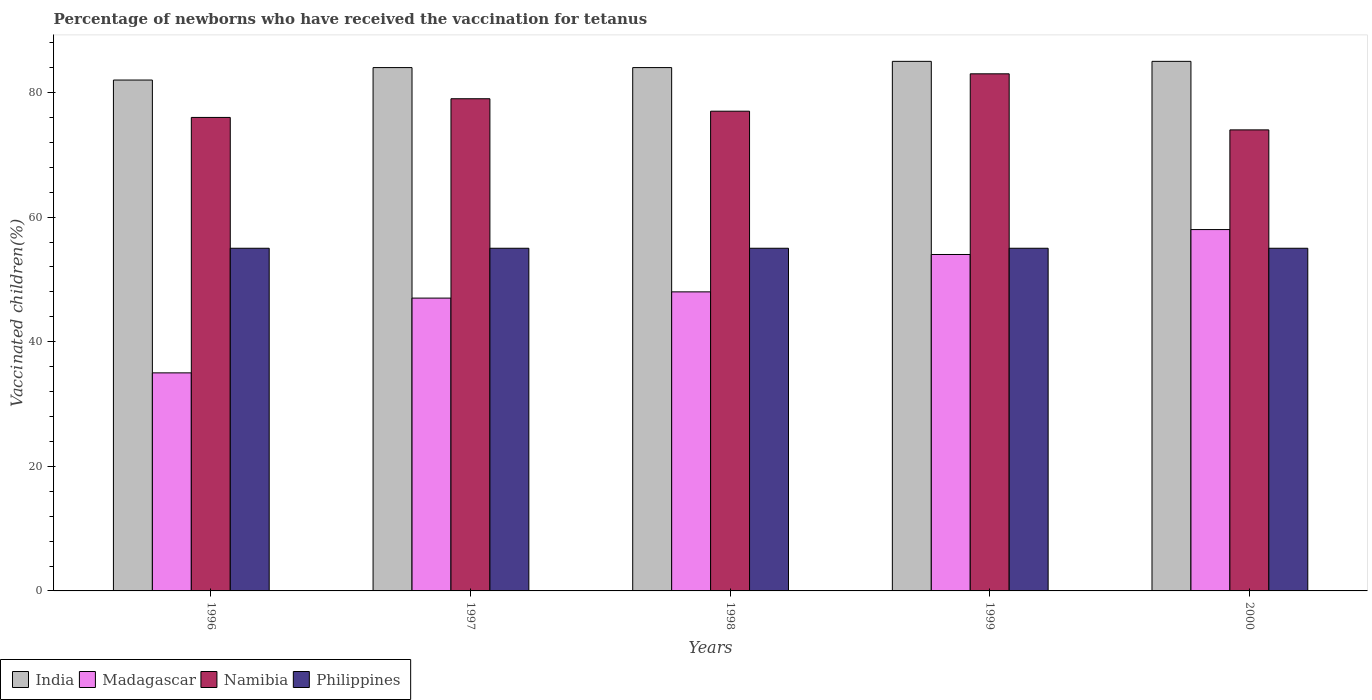Are the number of bars on each tick of the X-axis equal?
Keep it short and to the point. Yes. How many bars are there on the 3rd tick from the left?
Offer a very short reply. 4. What is the percentage of vaccinated children in Philippines in 1997?
Your answer should be very brief. 55. Across all years, what is the maximum percentage of vaccinated children in Philippines?
Give a very brief answer. 55. Across all years, what is the minimum percentage of vaccinated children in Philippines?
Your answer should be very brief. 55. In which year was the percentage of vaccinated children in Philippines maximum?
Offer a terse response. 1996. What is the total percentage of vaccinated children in Namibia in the graph?
Offer a terse response. 389. What is the difference between the percentage of vaccinated children in Madagascar in 1996 and that in 1997?
Keep it short and to the point. -12. What is the difference between the percentage of vaccinated children in India in 2000 and the percentage of vaccinated children in Madagascar in 1996?
Your response must be concise. 50. What is the average percentage of vaccinated children in Philippines per year?
Offer a very short reply. 55. In the year 1997, what is the difference between the percentage of vaccinated children in India and percentage of vaccinated children in Philippines?
Offer a very short reply. 29. In how many years, is the percentage of vaccinated children in Madagascar greater than 72 %?
Offer a very short reply. 0. What is the ratio of the percentage of vaccinated children in India in 1996 to that in 2000?
Keep it short and to the point. 0.96. What is the difference between the highest and the second highest percentage of vaccinated children in Madagascar?
Provide a succinct answer. 4. Is it the case that in every year, the sum of the percentage of vaccinated children in India and percentage of vaccinated children in Philippines is greater than the sum of percentage of vaccinated children in Namibia and percentage of vaccinated children in Madagascar?
Offer a terse response. Yes. What does the 3rd bar from the right in 1996 represents?
Your answer should be very brief. Madagascar. Is it the case that in every year, the sum of the percentage of vaccinated children in Namibia and percentage of vaccinated children in Philippines is greater than the percentage of vaccinated children in India?
Your response must be concise. Yes. Are all the bars in the graph horizontal?
Provide a short and direct response. No. How many years are there in the graph?
Give a very brief answer. 5. Does the graph contain grids?
Offer a terse response. No. What is the title of the graph?
Your answer should be very brief. Percentage of newborns who have received the vaccination for tetanus. Does "Guinea-Bissau" appear as one of the legend labels in the graph?
Provide a short and direct response. No. What is the label or title of the Y-axis?
Provide a short and direct response. Vaccinated children(%). What is the Vaccinated children(%) in India in 1996?
Provide a succinct answer. 82. What is the Vaccinated children(%) of Madagascar in 1996?
Offer a very short reply. 35. What is the Vaccinated children(%) of Philippines in 1996?
Give a very brief answer. 55. What is the Vaccinated children(%) in Madagascar in 1997?
Make the answer very short. 47. What is the Vaccinated children(%) of Namibia in 1997?
Your response must be concise. 79. What is the Vaccinated children(%) of India in 1998?
Make the answer very short. 84. What is the Vaccinated children(%) of Madagascar in 1998?
Your answer should be compact. 48. What is the Vaccinated children(%) in Philippines in 1998?
Your answer should be very brief. 55. What is the Vaccinated children(%) in India in 1999?
Offer a very short reply. 85. What is the Vaccinated children(%) of Madagascar in 1999?
Ensure brevity in your answer.  54. What is the Vaccinated children(%) in Philippines in 1999?
Offer a terse response. 55. What is the Vaccinated children(%) in India in 2000?
Offer a very short reply. 85. What is the Vaccinated children(%) in Madagascar in 2000?
Make the answer very short. 58. What is the Vaccinated children(%) in Namibia in 2000?
Ensure brevity in your answer.  74. What is the Vaccinated children(%) of Philippines in 2000?
Provide a short and direct response. 55. Across all years, what is the maximum Vaccinated children(%) of India?
Your answer should be compact. 85. Across all years, what is the minimum Vaccinated children(%) in Madagascar?
Your response must be concise. 35. Across all years, what is the minimum Vaccinated children(%) in Namibia?
Offer a terse response. 74. Across all years, what is the minimum Vaccinated children(%) of Philippines?
Provide a short and direct response. 55. What is the total Vaccinated children(%) in India in the graph?
Your answer should be compact. 420. What is the total Vaccinated children(%) in Madagascar in the graph?
Your answer should be compact. 242. What is the total Vaccinated children(%) of Namibia in the graph?
Your response must be concise. 389. What is the total Vaccinated children(%) of Philippines in the graph?
Your response must be concise. 275. What is the difference between the Vaccinated children(%) in India in 1996 and that in 1997?
Your answer should be very brief. -2. What is the difference between the Vaccinated children(%) of Madagascar in 1996 and that in 1997?
Offer a terse response. -12. What is the difference between the Vaccinated children(%) in Namibia in 1996 and that in 1998?
Keep it short and to the point. -1. What is the difference between the Vaccinated children(%) in Philippines in 1996 and that in 1998?
Your response must be concise. 0. What is the difference between the Vaccinated children(%) in Namibia in 1996 and that in 1999?
Keep it short and to the point. -7. What is the difference between the Vaccinated children(%) in Philippines in 1996 and that in 1999?
Make the answer very short. 0. What is the difference between the Vaccinated children(%) in Madagascar in 1996 and that in 2000?
Your answer should be compact. -23. What is the difference between the Vaccinated children(%) of Namibia in 1996 and that in 2000?
Your answer should be very brief. 2. What is the difference between the Vaccinated children(%) of Philippines in 1996 and that in 2000?
Your answer should be very brief. 0. What is the difference between the Vaccinated children(%) in India in 1997 and that in 1998?
Your response must be concise. 0. What is the difference between the Vaccinated children(%) of India in 1997 and that in 1999?
Make the answer very short. -1. What is the difference between the Vaccinated children(%) in Madagascar in 1997 and that in 1999?
Your answer should be compact. -7. What is the difference between the Vaccinated children(%) in India in 1997 and that in 2000?
Make the answer very short. -1. What is the difference between the Vaccinated children(%) in Philippines in 1997 and that in 2000?
Offer a very short reply. 0. What is the difference between the Vaccinated children(%) of India in 1998 and that in 1999?
Make the answer very short. -1. What is the difference between the Vaccinated children(%) in Namibia in 1998 and that in 1999?
Offer a terse response. -6. What is the difference between the Vaccinated children(%) in Philippines in 1998 and that in 1999?
Provide a short and direct response. 0. What is the difference between the Vaccinated children(%) in Madagascar in 1998 and that in 2000?
Make the answer very short. -10. What is the difference between the Vaccinated children(%) in Namibia in 1998 and that in 2000?
Keep it short and to the point. 3. What is the difference between the Vaccinated children(%) in Madagascar in 1999 and that in 2000?
Ensure brevity in your answer.  -4. What is the difference between the Vaccinated children(%) of Namibia in 1999 and that in 2000?
Give a very brief answer. 9. What is the difference between the Vaccinated children(%) in Philippines in 1999 and that in 2000?
Ensure brevity in your answer.  0. What is the difference between the Vaccinated children(%) of India in 1996 and the Vaccinated children(%) of Madagascar in 1997?
Make the answer very short. 35. What is the difference between the Vaccinated children(%) of Madagascar in 1996 and the Vaccinated children(%) of Namibia in 1997?
Make the answer very short. -44. What is the difference between the Vaccinated children(%) in Madagascar in 1996 and the Vaccinated children(%) in Philippines in 1997?
Your answer should be compact. -20. What is the difference between the Vaccinated children(%) of India in 1996 and the Vaccinated children(%) of Namibia in 1998?
Offer a very short reply. 5. What is the difference between the Vaccinated children(%) in Madagascar in 1996 and the Vaccinated children(%) in Namibia in 1998?
Give a very brief answer. -42. What is the difference between the Vaccinated children(%) of Madagascar in 1996 and the Vaccinated children(%) of Philippines in 1998?
Provide a short and direct response. -20. What is the difference between the Vaccinated children(%) of India in 1996 and the Vaccinated children(%) of Philippines in 1999?
Provide a short and direct response. 27. What is the difference between the Vaccinated children(%) in Madagascar in 1996 and the Vaccinated children(%) in Namibia in 1999?
Offer a very short reply. -48. What is the difference between the Vaccinated children(%) in Madagascar in 1996 and the Vaccinated children(%) in Philippines in 1999?
Provide a short and direct response. -20. What is the difference between the Vaccinated children(%) of India in 1996 and the Vaccinated children(%) of Philippines in 2000?
Offer a terse response. 27. What is the difference between the Vaccinated children(%) of Madagascar in 1996 and the Vaccinated children(%) of Namibia in 2000?
Your answer should be very brief. -39. What is the difference between the Vaccinated children(%) of Madagascar in 1996 and the Vaccinated children(%) of Philippines in 2000?
Make the answer very short. -20. What is the difference between the Vaccinated children(%) in India in 1997 and the Vaccinated children(%) in Namibia in 1998?
Your response must be concise. 7. What is the difference between the Vaccinated children(%) in India in 1997 and the Vaccinated children(%) in Philippines in 1998?
Offer a very short reply. 29. What is the difference between the Vaccinated children(%) of Madagascar in 1997 and the Vaccinated children(%) of Philippines in 1998?
Give a very brief answer. -8. What is the difference between the Vaccinated children(%) in India in 1997 and the Vaccinated children(%) in Philippines in 1999?
Keep it short and to the point. 29. What is the difference between the Vaccinated children(%) of Madagascar in 1997 and the Vaccinated children(%) of Namibia in 1999?
Keep it short and to the point. -36. What is the difference between the Vaccinated children(%) in Namibia in 1997 and the Vaccinated children(%) in Philippines in 1999?
Offer a very short reply. 24. What is the difference between the Vaccinated children(%) of India in 1997 and the Vaccinated children(%) of Namibia in 2000?
Offer a very short reply. 10. What is the difference between the Vaccinated children(%) in India in 1997 and the Vaccinated children(%) in Philippines in 2000?
Give a very brief answer. 29. What is the difference between the Vaccinated children(%) in Madagascar in 1997 and the Vaccinated children(%) in Philippines in 2000?
Offer a very short reply. -8. What is the difference between the Vaccinated children(%) of India in 1998 and the Vaccinated children(%) of Philippines in 1999?
Keep it short and to the point. 29. What is the difference between the Vaccinated children(%) in Madagascar in 1998 and the Vaccinated children(%) in Namibia in 1999?
Your response must be concise. -35. What is the difference between the Vaccinated children(%) of Madagascar in 1998 and the Vaccinated children(%) of Philippines in 1999?
Your response must be concise. -7. What is the difference between the Vaccinated children(%) of India in 1998 and the Vaccinated children(%) of Madagascar in 2000?
Give a very brief answer. 26. What is the difference between the Vaccinated children(%) of India in 1998 and the Vaccinated children(%) of Philippines in 2000?
Offer a terse response. 29. What is the difference between the Vaccinated children(%) of Madagascar in 1998 and the Vaccinated children(%) of Philippines in 2000?
Keep it short and to the point. -7. What is the difference between the Vaccinated children(%) of Namibia in 1998 and the Vaccinated children(%) of Philippines in 2000?
Make the answer very short. 22. What is the difference between the Vaccinated children(%) in India in 1999 and the Vaccinated children(%) in Philippines in 2000?
Offer a terse response. 30. What is the difference between the Vaccinated children(%) of Madagascar in 1999 and the Vaccinated children(%) of Philippines in 2000?
Your answer should be very brief. -1. What is the average Vaccinated children(%) of Madagascar per year?
Make the answer very short. 48.4. What is the average Vaccinated children(%) in Namibia per year?
Your response must be concise. 77.8. What is the average Vaccinated children(%) in Philippines per year?
Make the answer very short. 55. In the year 1996, what is the difference between the Vaccinated children(%) of India and Vaccinated children(%) of Madagascar?
Offer a terse response. 47. In the year 1996, what is the difference between the Vaccinated children(%) in Madagascar and Vaccinated children(%) in Namibia?
Provide a short and direct response. -41. In the year 1996, what is the difference between the Vaccinated children(%) in Madagascar and Vaccinated children(%) in Philippines?
Provide a short and direct response. -20. In the year 1997, what is the difference between the Vaccinated children(%) in Madagascar and Vaccinated children(%) in Namibia?
Your answer should be compact. -32. In the year 1997, what is the difference between the Vaccinated children(%) in Namibia and Vaccinated children(%) in Philippines?
Provide a short and direct response. 24. In the year 1998, what is the difference between the Vaccinated children(%) in India and Vaccinated children(%) in Philippines?
Provide a short and direct response. 29. In the year 1998, what is the difference between the Vaccinated children(%) of Madagascar and Vaccinated children(%) of Namibia?
Ensure brevity in your answer.  -29. In the year 1998, what is the difference between the Vaccinated children(%) of Namibia and Vaccinated children(%) of Philippines?
Provide a succinct answer. 22. In the year 1999, what is the difference between the Vaccinated children(%) in India and Vaccinated children(%) in Madagascar?
Make the answer very short. 31. In the year 1999, what is the difference between the Vaccinated children(%) of Namibia and Vaccinated children(%) of Philippines?
Offer a terse response. 28. In the year 2000, what is the difference between the Vaccinated children(%) in India and Vaccinated children(%) in Madagascar?
Give a very brief answer. 27. In the year 2000, what is the difference between the Vaccinated children(%) of India and Vaccinated children(%) of Namibia?
Keep it short and to the point. 11. In the year 2000, what is the difference between the Vaccinated children(%) in India and Vaccinated children(%) in Philippines?
Provide a succinct answer. 30. In the year 2000, what is the difference between the Vaccinated children(%) in Madagascar and Vaccinated children(%) in Namibia?
Ensure brevity in your answer.  -16. In the year 2000, what is the difference between the Vaccinated children(%) of Madagascar and Vaccinated children(%) of Philippines?
Keep it short and to the point. 3. In the year 2000, what is the difference between the Vaccinated children(%) of Namibia and Vaccinated children(%) of Philippines?
Your answer should be compact. 19. What is the ratio of the Vaccinated children(%) in India in 1996 to that in 1997?
Provide a short and direct response. 0.98. What is the ratio of the Vaccinated children(%) in Madagascar in 1996 to that in 1997?
Give a very brief answer. 0.74. What is the ratio of the Vaccinated children(%) in India in 1996 to that in 1998?
Provide a short and direct response. 0.98. What is the ratio of the Vaccinated children(%) of Madagascar in 1996 to that in 1998?
Ensure brevity in your answer.  0.73. What is the ratio of the Vaccinated children(%) in Philippines in 1996 to that in 1998?
Give a very brief answer. 1. What is the ratio of the Vaccinated children(%) of India in 1996 to that in 1999?
Offer a very short reply. 0.96. What is the ratio of the Vaccinated children(%) of Madagascar in 1996 to that in 1999?
Make the answer very short. 0.65. What is the ratio of the Vaccinated children(%) in Namibia in 1996 to that in 1999?
Your answer should be very brief. 0.92. What is the ratio of the Vaccinated children(%) in India in 1996 to that in 2000?
Your answer should be compact. 0.96. What is the ratio of the Vaccinated children(%) in Madagascar in 1996 to that in 2000?
Provide a succinct answer. 0.6. What is the ratio of the Vaccinated children(%) of India in 1997 to that in 1998?
Ensure brevity in your answer.  1. What is the ratio of the Vaccinated children(%) of Madagascar in 1997 to that in 1998?
Make the answer very short. 0.98. What is the ratio of the Vaccinated children(%) in Namibia in 1997 to that in 1998?
Give a very brief answer. 1.03. What is the ratio of the Vaccinated children(%) in Philippines in 1997 to that in 1998?
Provide a short and direct response. 1. What is the ratio of the Vaccinated children(%) in India in 1997 to that in 1999?
Your answer should be very brief. 0.99. What is the ratio of the Vaccinated children(%) of Madagascar in 1997 to that in 1999?
Provide a succinct answer. 0.87. What is the ratio of the Vaccinated children(%) of Namibia in 1997 to that in 1999?
Provide a short and direct response. 0.95. What is the ratio of the Vaccinated children(%) in India in 1997 to that in 2000?
Keep it short and to the point. 0.99. What is the ratio of the Vaccinated children(%) of Madagascar in 1997 to that in 2000?
Keep it short and to the point. 0.81. What is the ratio of the Vaccinated children(%) in Namibia in 1997 to that in 2000?
Keep it short and to the point. 1.07. What is the ratio of the Vaccinated children(%) of Philippines in 1997 to that in 2000?
Ensure brevity in your answer.  1. What is the ratio of the Vaccinated children(%) of India in 1998 to that in 1999?
Ensure brevity in your answer.  0.99. What is the ratio of the Vaccinated children(%) in Namibia in 1998 to that in 1999?
Offer a terse response. 0.93. What is the ratio of the Vaccinated children(%) in Philippines in 1998 to that in 1999?
Ensure brevity in your answer.  1. What is the ratio of the Vaccinated children(%) in Madagascar in 1998 to that in 2000?
Offer a very short reply. 0.83. What is the ratio of the Vaccinated children(%) of Namibia in 1998 to that in 2000?
Provide a short and direct response. 1.04. What is the ratio of the Vaccinated children(%) of India in 1999 to that in 2000?
Make the answer very short. 1. What is the ratio of the Vaccinated children(%) in Namibia in 1999 to that in 2000?
Provide a short and direct response. 1.12. What is the ratio of the Vaccinated children(%) of Philippines in 1999 to that in 2000?
Give a very brief answer. 1. What is the difference between the highest and the second highest Vaccinated children(%) in Philippines?
Give a very brief answer. 0. What is the difference between the highest and the lowest Vaccinated children(%) in India?
Give a very brief answer. 3. What is the difference between the highest and the lowest Vaccinated children(%) of Madagascar?
Keep it short and to the point. 23. What is the difference between the highest and the lowest Vaccinated children(%) of Namibia?
Provide a short and direct response. 9. What is the difference between the highest and the lowest Vaccinated children(%) in Philippines?
Your answer should be very brief. 0. 